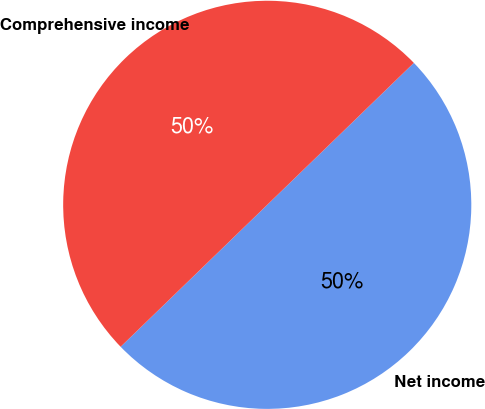Convert chart. <chart><loc_0><loc_0><loc_500><loc_500><pie_chart><fcel>Net income<fcel>Comprehensive income<nl><fcel>50.0%<fcel>50.0%<nl></chart> 